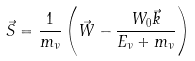<formula> <loc_0><loc_0><loc_500><loc_500>\vec { S } = \frac { 1 } { m _ { \nu } } \left ( \vec { W } - \frac { W _ { 0 } \vec { k } } { E _ { \nu } + m _ { \nu } } \right )</formula> 